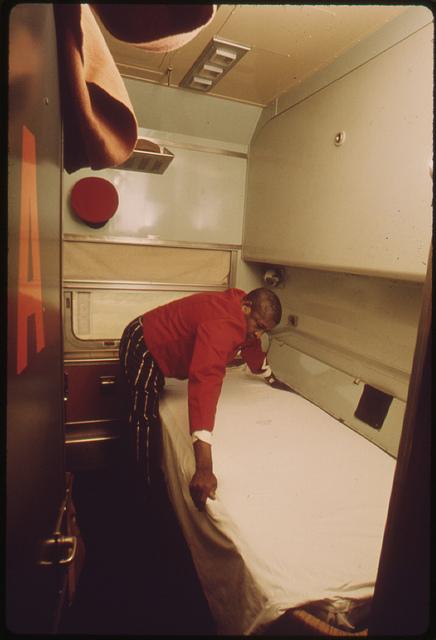What letter is on the door?
Keep it brief. A. What is the man doing?
Answer briefly. Making bed. What is the man working on?
Be succinct. Bed. 